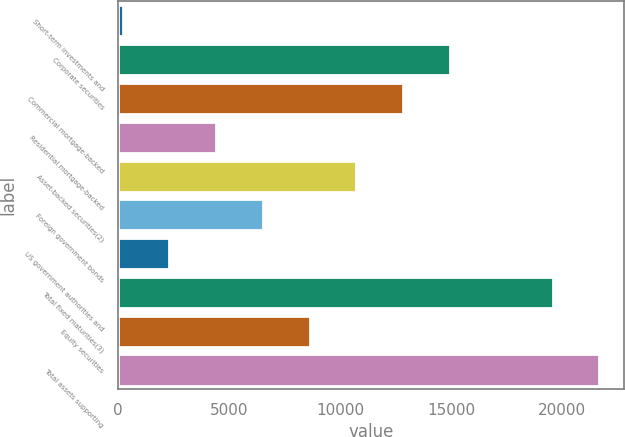<chart> <loc_0><loc_0><loc_500><loc_500><bar_chart><fcel>Short-term investments and<fcel>Corporate securities<fcel>Commercial mortgage-backed<fcel>Residential mortgage-backed<fcel>Asset-backed securities(2)<fcel>Foreign government bonds<fcel>US government authorities and<fcel>Total fixed maturities(3)<fcel>Equity securities<fcel>Total assets supporting<nl><fcel>215<fcel>14942.3<fcel>12838.4<fcel>4422.8<fcel>10734.5<fcel>6526.7<fcel>2318.9<fcel>19579<fcel>8630.6<fcel>21682.9<nl></chart> 